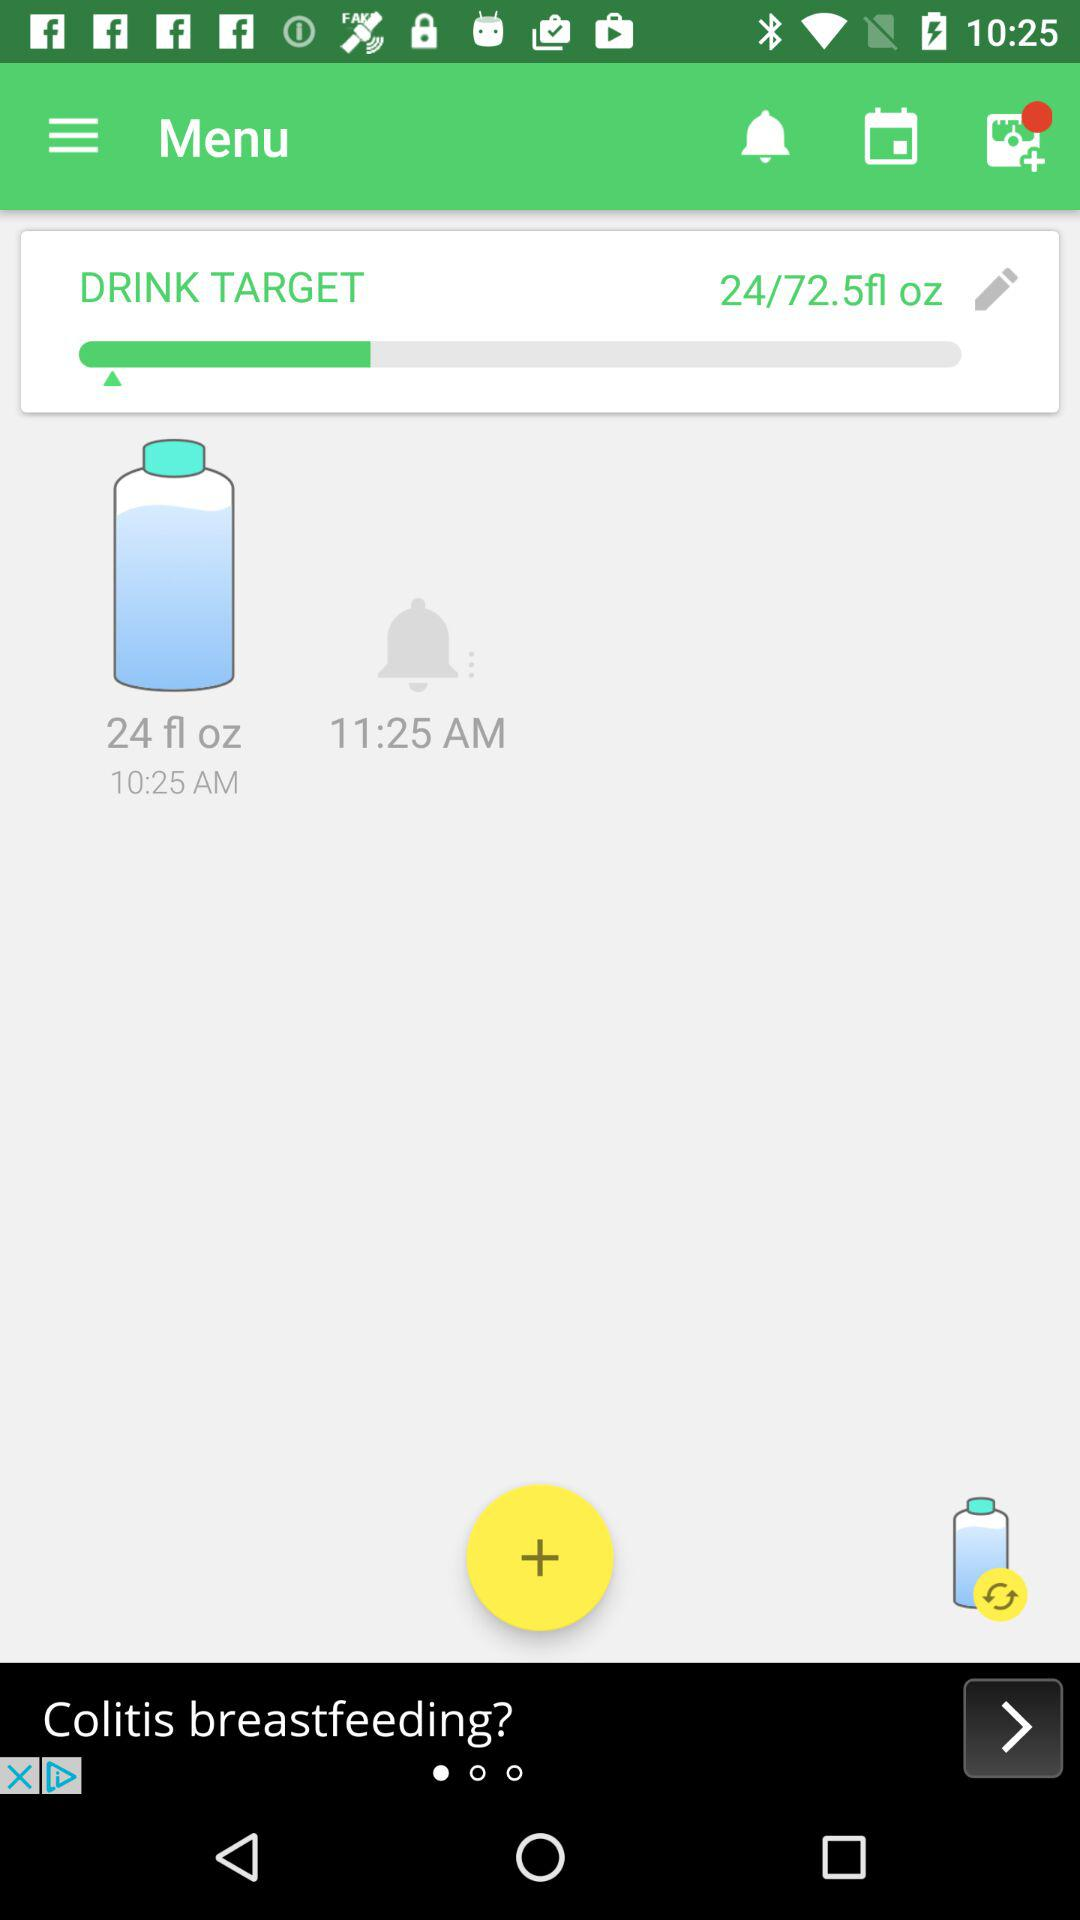What time is the alarm set? The alarm is set for 11:25 AM. 